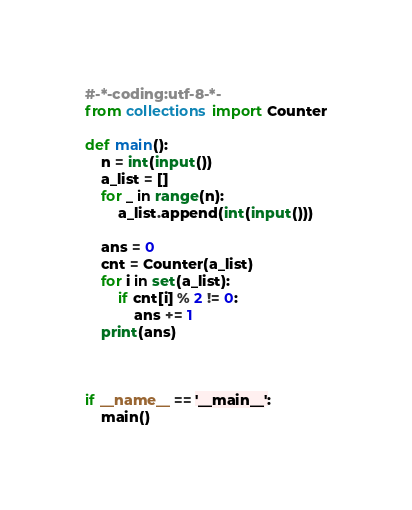Convert code to text. <code><loc_0><loc_0><loc_500><loc_500><_Python_>#-*-coding:utf-8-*-
from collections import Counter

def main():
    n = int(input())
    a_list = []
    for _ in range(n):
        a_list.append(int(input()))
    
    ans = 0
    cnt = Counter(a_list)
    for i in set(a_list):
        if cnt[i] % 2 != 0:
            ans += 1
    print(ans)



if __name__ == '__main__':
    main()</code> 